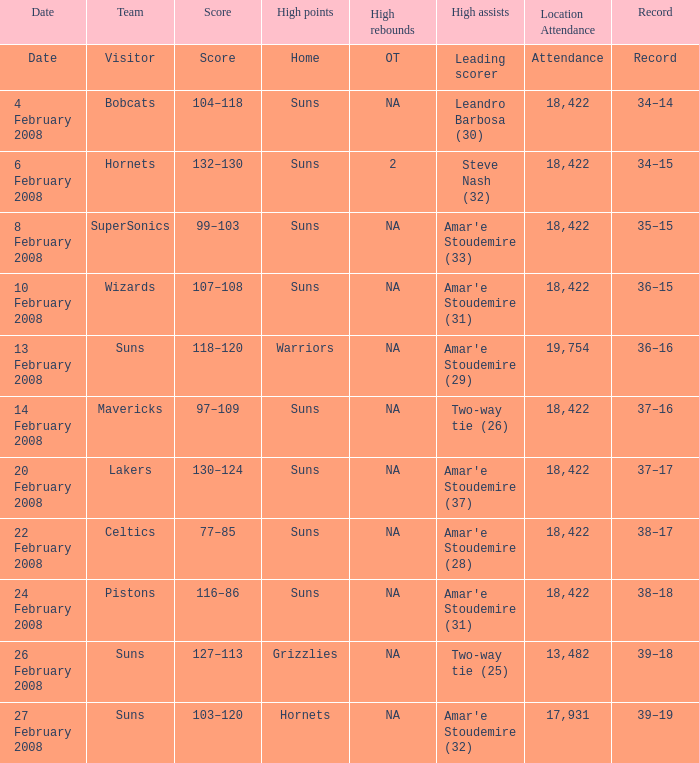How many high assists did the Lakers have? Amar'e Stoudemire (37). 